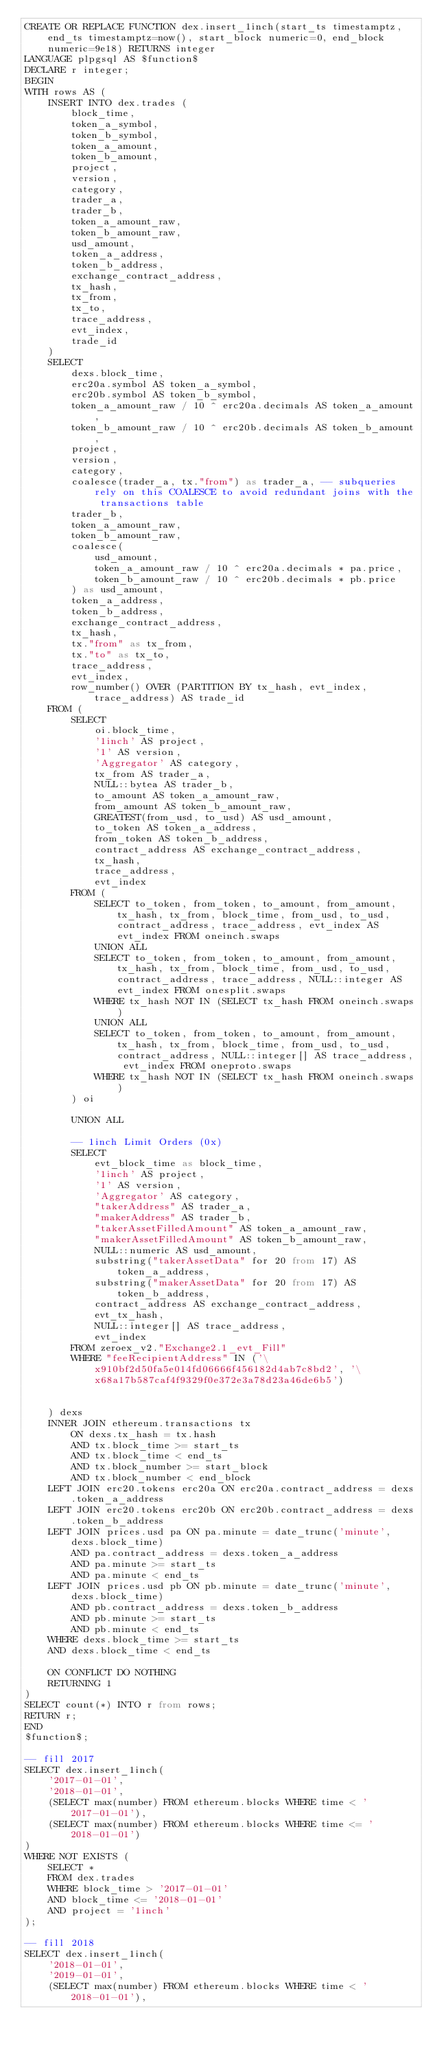Convert code to text. <code><loc_0><loc_0><loc_500><loc_500><_SQL_>CREATE OR REPLACE FUNCTION dex.insert_1inch(start_ts timestamptz, end_ts timestamptz=now(), start_block numeric=0, end_block numeric=9e18) RETURNS integer
LANGUAGE plpgsql AS $function$
DECLARE r integer;
BEGIN
WITH rows AS (
    INSERT INTO dex.trades (
        block_time,
        token_a_symbol,
        token_b_symbol,
        token_a_amount,
        token_b_amount,
        project,
        version,
        category,
        trader_a,
        trader_b,
        token_a_amount_raw,
        token_b_amount_raw,
        usd_amount,
        token_a_address,
        token_b_address,
        exchange_contract_address,
        tx_hash,
        tx_from,
        tx_to,
        trace_address,
        evt_index,
        trade_id
    )
    SELECT
        dexs.block_time,
        erc20a.symbol AS token_a_symbol,
        erc20b.symbol AS token_b_symbol,
        token_a_amount_raw / 10 ^ erc20a.decimals AS token_a_amount,
        token_b_amount_raw / 10 ^ erc20b.decimals AS token_b_amount,
        project,
        version,
        category,
        coalesce(trader_a, tx."from") as trader_a, -- subqueries rely on this COALESCE to avoid redundant joins with the transactions table
        trader_b,
        token_a_amount_raw,
        token_b_amount_raw,
        coalesce(
            usd_amount,
            token_a_amount_raw / 10 ^ erc20a.decimals * pa.price,
            token_b_amount_raw / 10 ^ erc20b.decimals * pb.price
        ) as usd_amount,
        token_a_address,
        token_b_address,
        exchange_contract_address,
        tx_hash,
        tx."from" as tx_from,
        tx."to" as tx_to,
        trace_address,
        evt_index,
        row_number() OVER (PARTITION BY tx_hash, evt_index, trace_address) AS trade_id
    FROM (
        SELECT
            oi.block_time,
            '1inch' AS project,
            '1' AS version,
            'Aggregator' AS category,
            tx_from AS trader_a,
            NULL::bytea AS trader_b,
            to_amount AS token_a_amount_raw,
            from_amount AS token_b_amount_raw,
            GREATEST(from_usd, to_usd) AS usd_amount,
            to_token AS token_a_address,
            from_token AS token_b_address,
            contract_address AS exchange_contract_address,
            tx_hash,
            trace_address,
            evt_index
        FROM (
            SELECT to_token, from_token, to_amount, from_amount, tx_hash, tx_from, block_time, from_usd, to_usd, contract_address, trace_address, evt_index AS evt_index FROM oneinch.swaps
            UNION ALL
            SELECT to_token, from_token, to_amount, from_amount, tx_hash, tx_from, block_time, from_usd, to_usd, contract_address, trace_address, NULL::integer AS evt_index FROM onesplit.swaps
            WHERE tx_hash NOT IN (SELECT tx_hash FROM oneinch.swaps)
            UNION ALL
            SELECT to_token, from_token, to_amount, from_amount, tx_hash, tx_from, block_time, from_usd, to_usd, contract_address, NULL::integer[] AS trace_address, evt_index FROM oneproto.swaps
            WHERE tx_hash NOT IN (SELECT tx_hash FROM oneinch.swaps)
        ) oi

        UNION ALL

        -- 1inch Limit Orders (0x)
        SELECT
            evt_block_time as block_time,
            '1inch' AS project,
            '1' AS version,
            'Aggregator' AS category,
            "takerAddress" AS trader_a,
            "makerAddress" AS trader_b,
            "takerAssetFilledAmount" AS token_a_amount_raw,
            "makerAssetFilledAmount" AS token_b_amount_raw,
            NULL::numeric AS usd_amount,
            substring("takerAssetData" for 20 from 17) AS token_a_address,
            substring("makerAssetData" for 20 from 17) AS token_b_address,
            contract_address AS exchange_contract_address,
            evt_tx_hash,
            NULL::integer[] AS trace_address,
            evt_index
        FROM zeroex_v2."Exchange2.1_evt_Fill"
        WHERE "feeRecipientAddress" IN ('\x910bf2d50fa5e014fd06666f456182d4ab7c8bd2', '\x68a17b587caf4f9329f0e372e3a78d23a46de6b5')


    ) dexs
    INNER JOIN ethereum.transactions tx
        ON dexs.tx_hash = tx.hash
        AND tx.block_time >= start_ts
        AND tx.block_time < end_ts
        AND tx.block_number >= start_block
        AND tx.block_number < end_block
    LEFT JOIN erc20.tokens erc20a ON erc20a.contract_address = dexs.token_a_address
    LEFT JOIN erc20.tokens erc20b ON erc20b.contract_address = dexs.token_b_address
    LEFT JOIN prices.usd pa ON pa.minute = date_trunc('minute', dexs.block_time)
        AND pa.contract_address = dexs.token_a_address
        AND pa.minute >= start_ts
        AND pa.minute < end_ts
    LEFT JOIN prices.usd pb ON pb.minute = date_trunc('minute', dexs.block_time)
        AND pb.contract_address = dexs.token_b_address
        AND pb.minute >= start_ts
        AND pb.minute < end_ts
    WHERE dexs.block_time >= start_ts
    AND dexs.block_time < end_ts

    ON CONFLICT DO NOTHING
    RETURNING 1
)
SELECT count(*) INTO r from rows;
RETURN r;
END
$function$;

-- fill 2017
SELECT dex.insert_1inch(
    '2017-01-01',
    '2018-01-01',
    (SELECT max(number) FROM ethereum.blocks WHERE time < '2017-01-01'),
    (SELECT max(number) FROM ethereum.blocks WHERE time <= '2018-01-01')
)
WHERE NOT EXISTS (
    SELECT *
    FROM dex.trades
    WHERE block_time > '2017-01-01'
    AND block_time <= '2018-01-01'
    AND project = '1inch' 
);

-- fill 2018
SELECT dex.insert_1inch(
    '2018-01-01',
    '2019-01-01',
    (SELECT max(number) FROM ethereum.blocks WHERE time < '2018-01-01'),</code> 